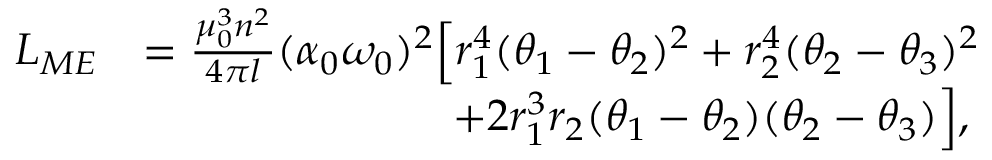<formula> <loc_0><loc_0><loc_500><loc_500>\begin{array} { r l } { L _ { M E } } & { = \frac { \mu _ { 0 } ^ { 3 } n ^ { 2 } } { 4 \pi l } ( \alpha _ { 0 } \omega _ { 0 } ) ^ { 2 } \left [ r _ { 1 } ^ { 4 } ( \theta _ { 1 } - \theta _ { 2 } ) ^ { 2 } + r _ { 2 } ^ { 4 } ( \theta _ { 2 } - \theta _ { 3 } ) ^ { 2 } } \\ & { \quad + 2 r _ { 1 } ^ { 3 } r _ { 2 } ( \theta _ { 1 } - \theta _ { 2 } ) ( \theta _ { 2 } - \theta _ { 3 } ) \right ] , } \end{array}</formula> 